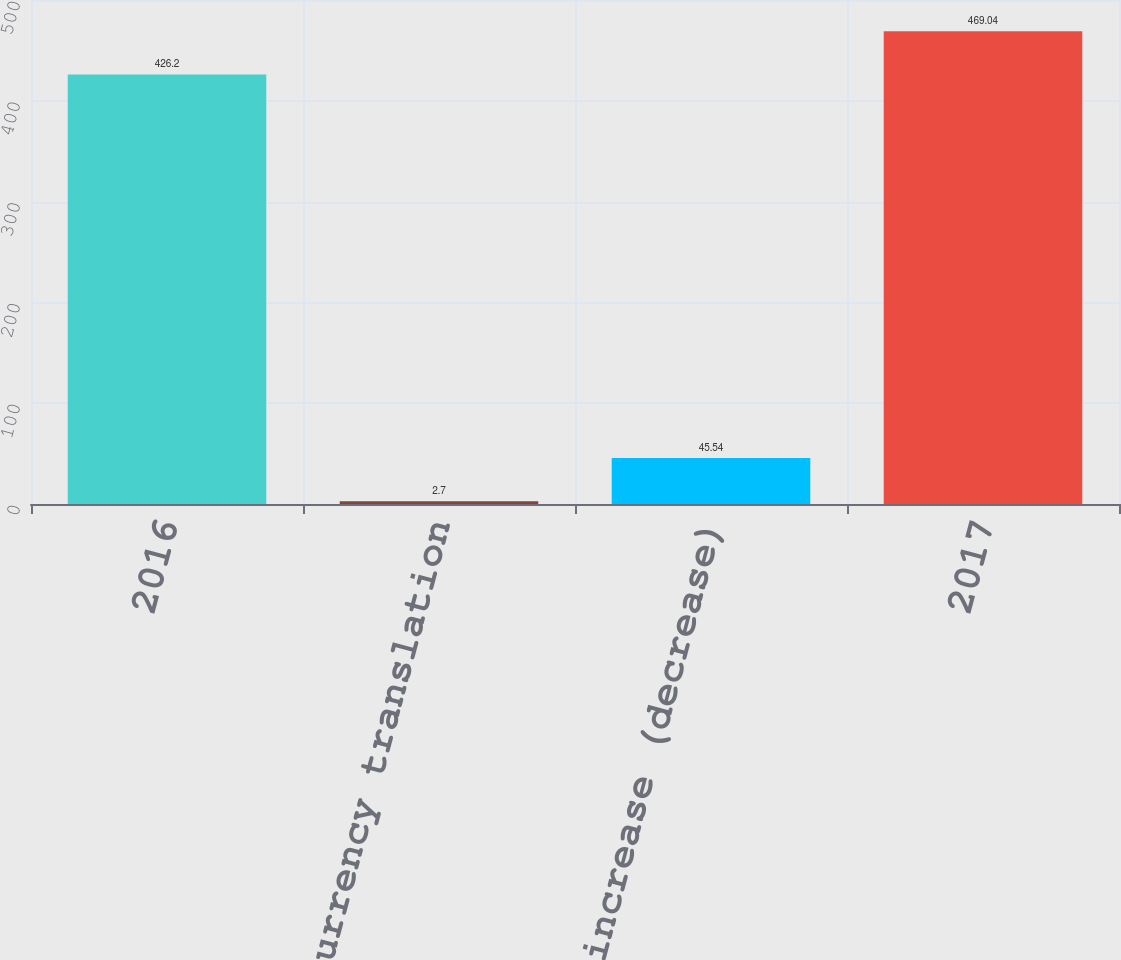Convert chart. <chart><loc_0><loc_0><loc_500><loc_500><bar_chart><fcel>2016<fcel>Currency translation<fcel>Total increase (decrease)<fcel>2017<nl><fcel>426.2<fcel>2.7<fcel>45.54<fcel>469.04<nl></chart> 